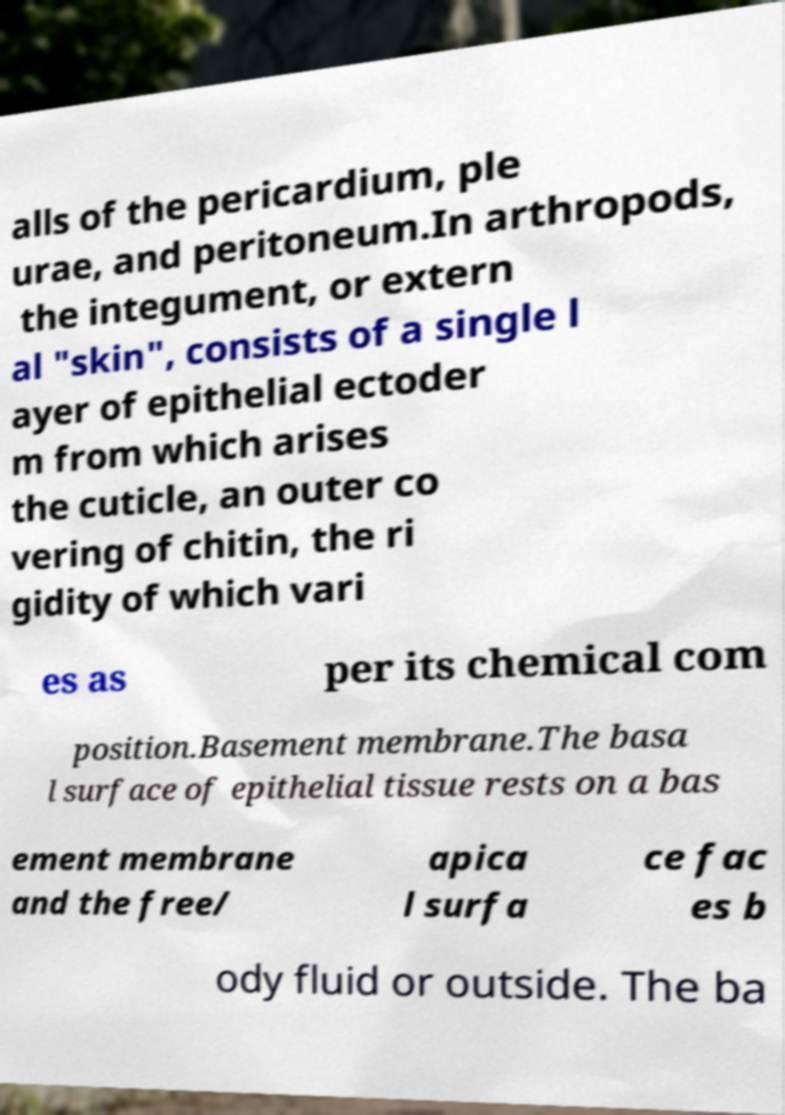Can you read and provide the text displayed in the image?This photo seems to have some interesting text. Can you extract and type it out for me? alls of the pericardium, ple urae, and peritoneum.In arthropods, the integument, or extern al "skin", consists of a single l ayer of epithelial ectoder m from which arises the cuticle, an outer co vering of chitin, the ri gidity of which vari es as per its chemical com position.Basement membrane.The basa l surface of epithelial tissue rests on a bas ement membrane and the free/ apica l surfa ce fac es b ody fluid or outside. The ba 